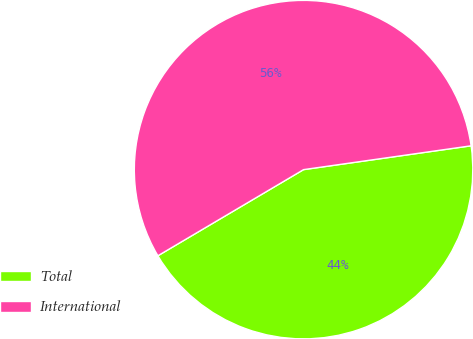<chart> <loc_0><loc_0><loc_500><loc_500><pie_chart><fcel>Total<fcel>International<nl><fcel>43.75%<fcel>56.25%<nl></chart> 